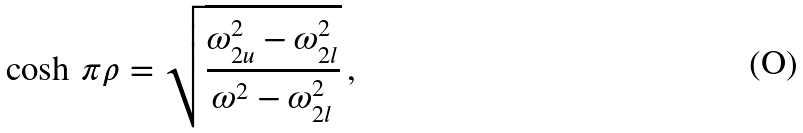<formula> <loc_0><loc_0><loc_500><loc_500>\cosh \, \pi \rho = \sqrt { \frac { \omega _ { 2 u } ^ { 2 } - \omega _ { 2 l } ^ { 2 } } { \omega ^ { 2 } - \omega _ { 2 l } ^ { 2 } } } \, ,</formula> 